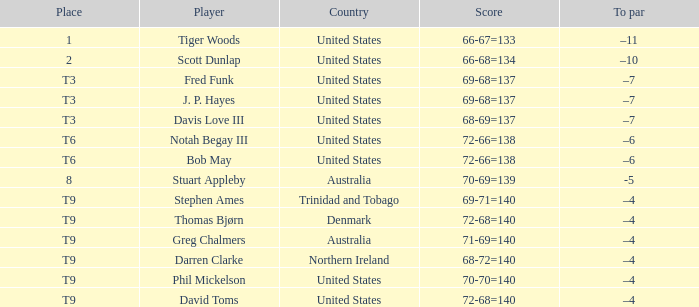For a score of 70-69=139, what would be the associated to par value? -5.0. 